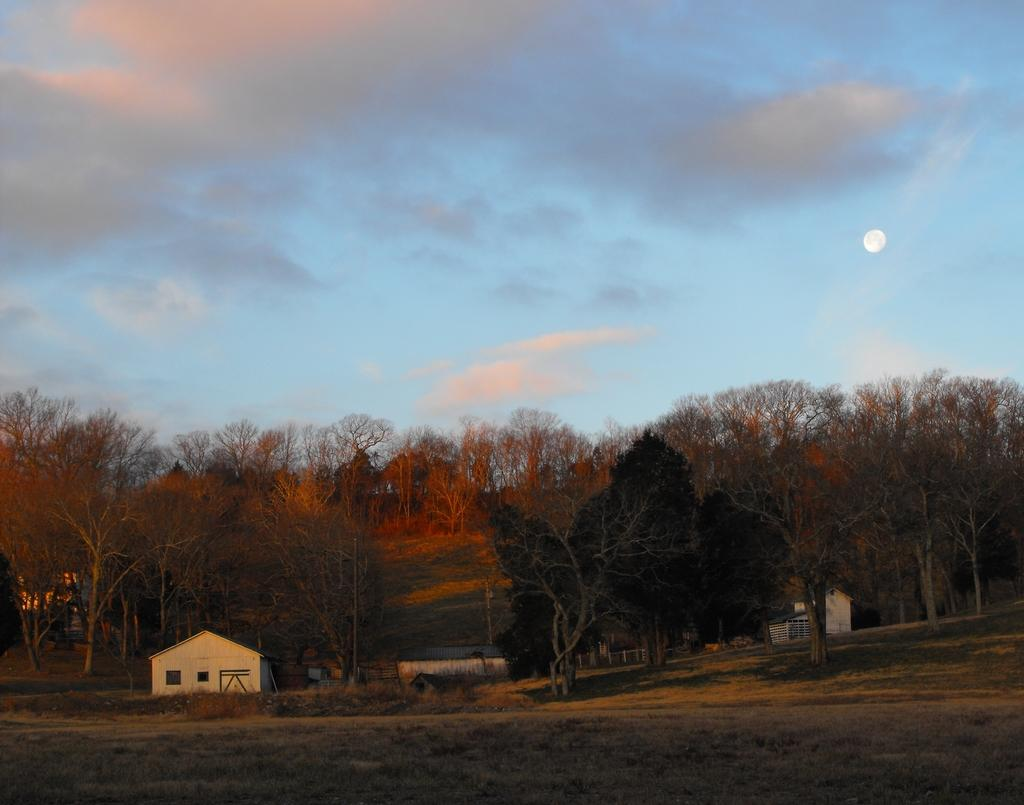What type of natural vegetation can be seen in the background of the image? There are trees in the background of the image. What type of structure is present in the image? There is a house in the image. What color are some of the objects in the image? There are objects that are white in color in the image. How would you describe the weather based on the sky in the image? The sky is cloudy in the image. What celestial body is visible in the sky? The moon is visible in the sky. What type of bait is being used to catch fish in the image? There is no fishing or bait present in the image. How many pies are visible on the table in the image? There are no pies visible in the image. 